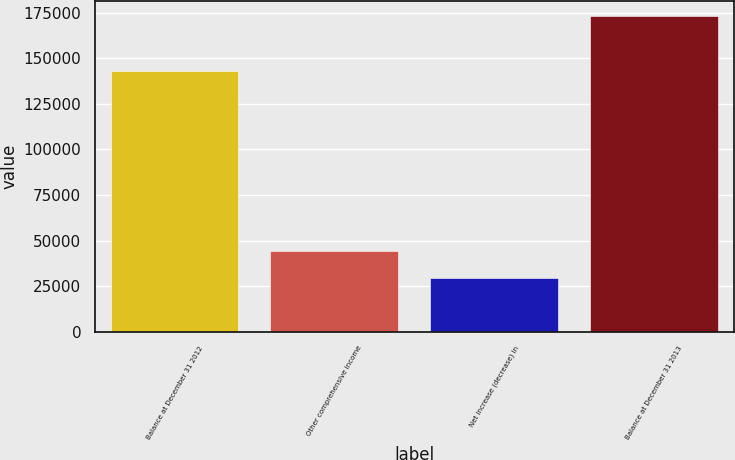Convert chart. <chart><loc_0><loc_0><loc_500><loc_500><bar_chart><fcel>Balance at December 31 2012<fcel>Other comprehensive income<fcel>Net increase (decrease) in<fcel>Balance at December 31 2013<nl><fcel>143142<fcel>44039.2<fcel>29725<fcel>172867<nl></chart> 